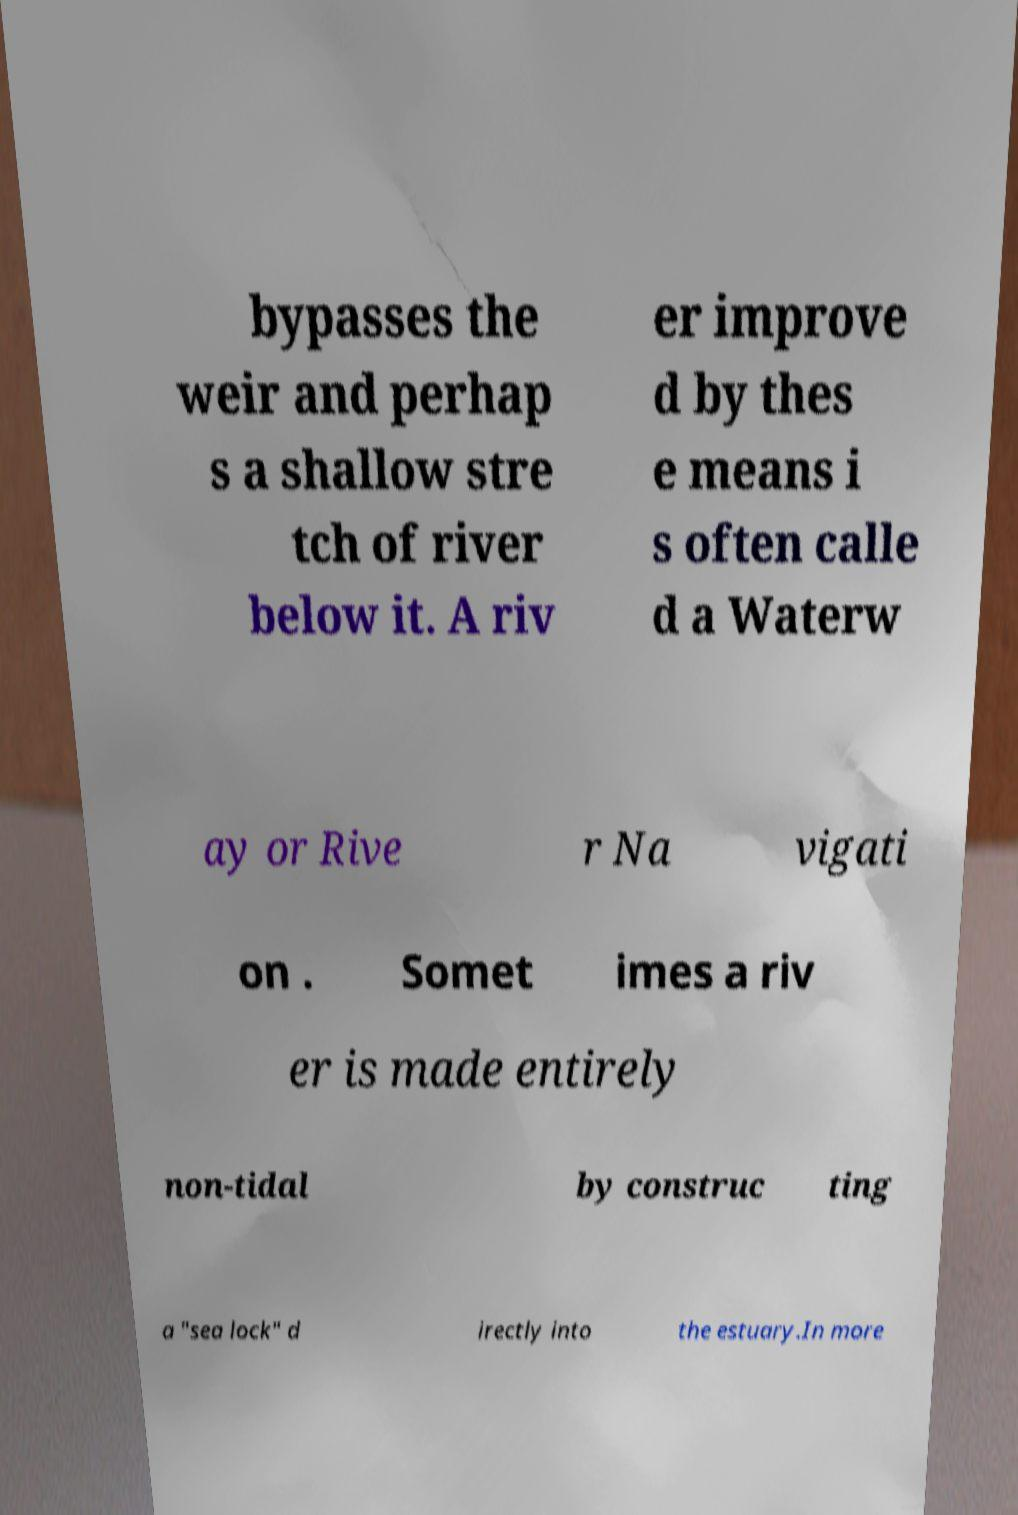Can you accurately transcribe the text from the provided image for me? bypasses the weir and perhap s a shallow stre tch of river below it. A riv er improve d by thes e means i s often calle d a Waterw ay or Rive r Na vigati on . Somet imes a riv er is made entirely non-tidal by construc ting a "sea lock" d irectly into the estuary.In more 